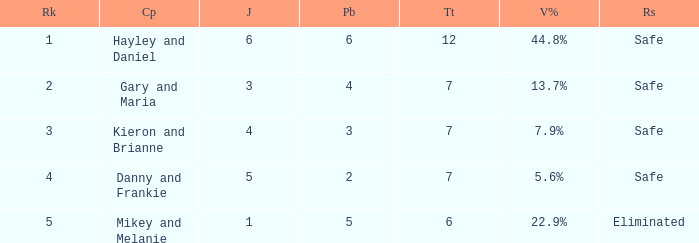What is the number of public that was there when the vote percentage was 22.9%? 1.0. Write the full table. {'header': ['Rk', 'Cp', 'J', 'Pb', 'Tt', 'V%', 'Rs'], 'rows': [['1', 'Hayley and Daniel', '6', '6', '12', '44.8%', 'Safe'], ['2', 'Gary and Maria', '3', '4', '7', '13.7%', 'Safe'], ['3', 'Kieron and Brianne', '4', '3', '7', '7.9%', 'Safe'], ['4', 'Danny and Frankie', '5', '2', '7', '5.6%', 'Safe'], ['5', 'Mikey and Melanie', '1', '5', '6', '22.9%', 'Eliminated']]} 